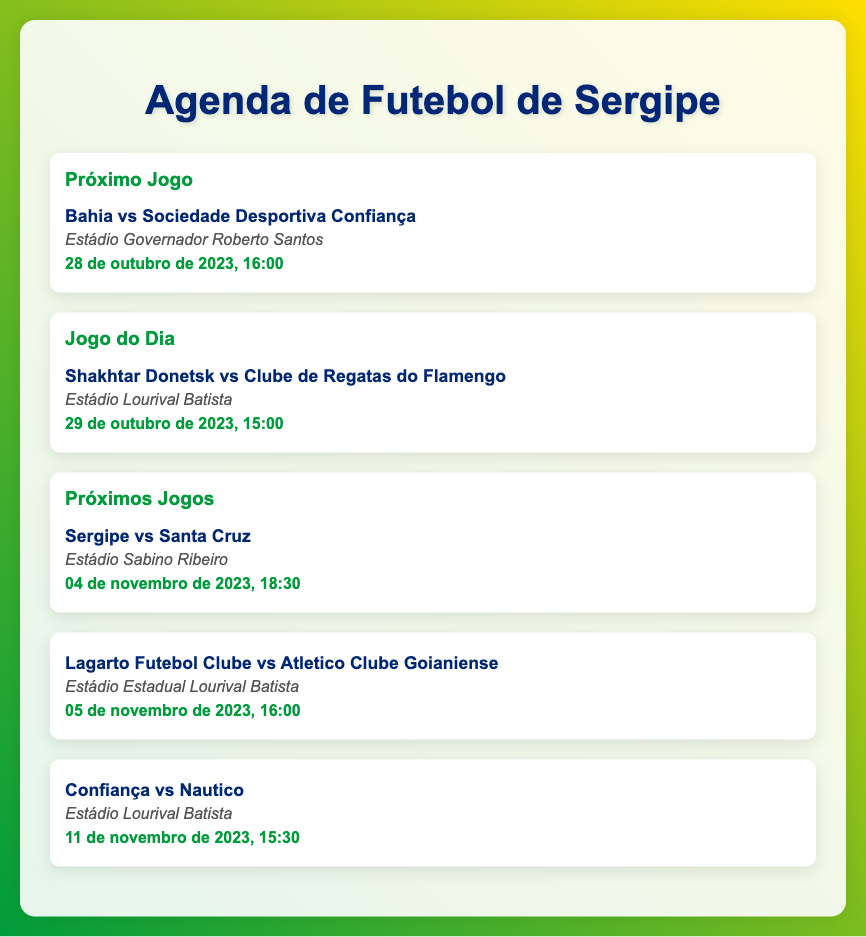what is the date of the next game for Bahia? The document states that Bahia will play on 28 de outubro de 2023.
Answer: 28 de outubro de 2023 what time does the game between Shakhtar Donetsk and Flamengo start? The document specifies that the game will start at 15:00.
Answer: 15:00 which venue will host the game between Sergipe and Santa Cruz? According to the document, the game will be held at Estádio Sabino Ribeiro.
Answer: Estádio Sabino Ribeiro who is playing on November 5, 2023? The document lists Lagarto Futebol Clube vs Atletico Clube Goianiense for that date.
Answer: Lagarto Futebol Clube vs Atletico Clube Goianiense how many games are listed for November 2023? The document shows three games scheduled for November 2023.
Answer: 3 what is the venue for the Confiança vs Nautico game? The venue mentioned for the Confiança versus Nautico game is Estádio Lourival Batista.
Answer: Estádio Lourival Batista which club is playing on October 29, 2023? The document mentions Clube de Regatas do Flamengo is playing on this date.
Answer: Clube de Regatas do Flamengo which fixture takes place first, Bahia vs Sociedade Desportiva Confiança or Sergipe vs Santa Cruz? The document states that Bahia vs Sociedade Desportiva Confiança is scheduled before Sergipe vs Santa Cruz on their respective dates.
Answer: Bahia vs Sociedade Desportiva Confiança 